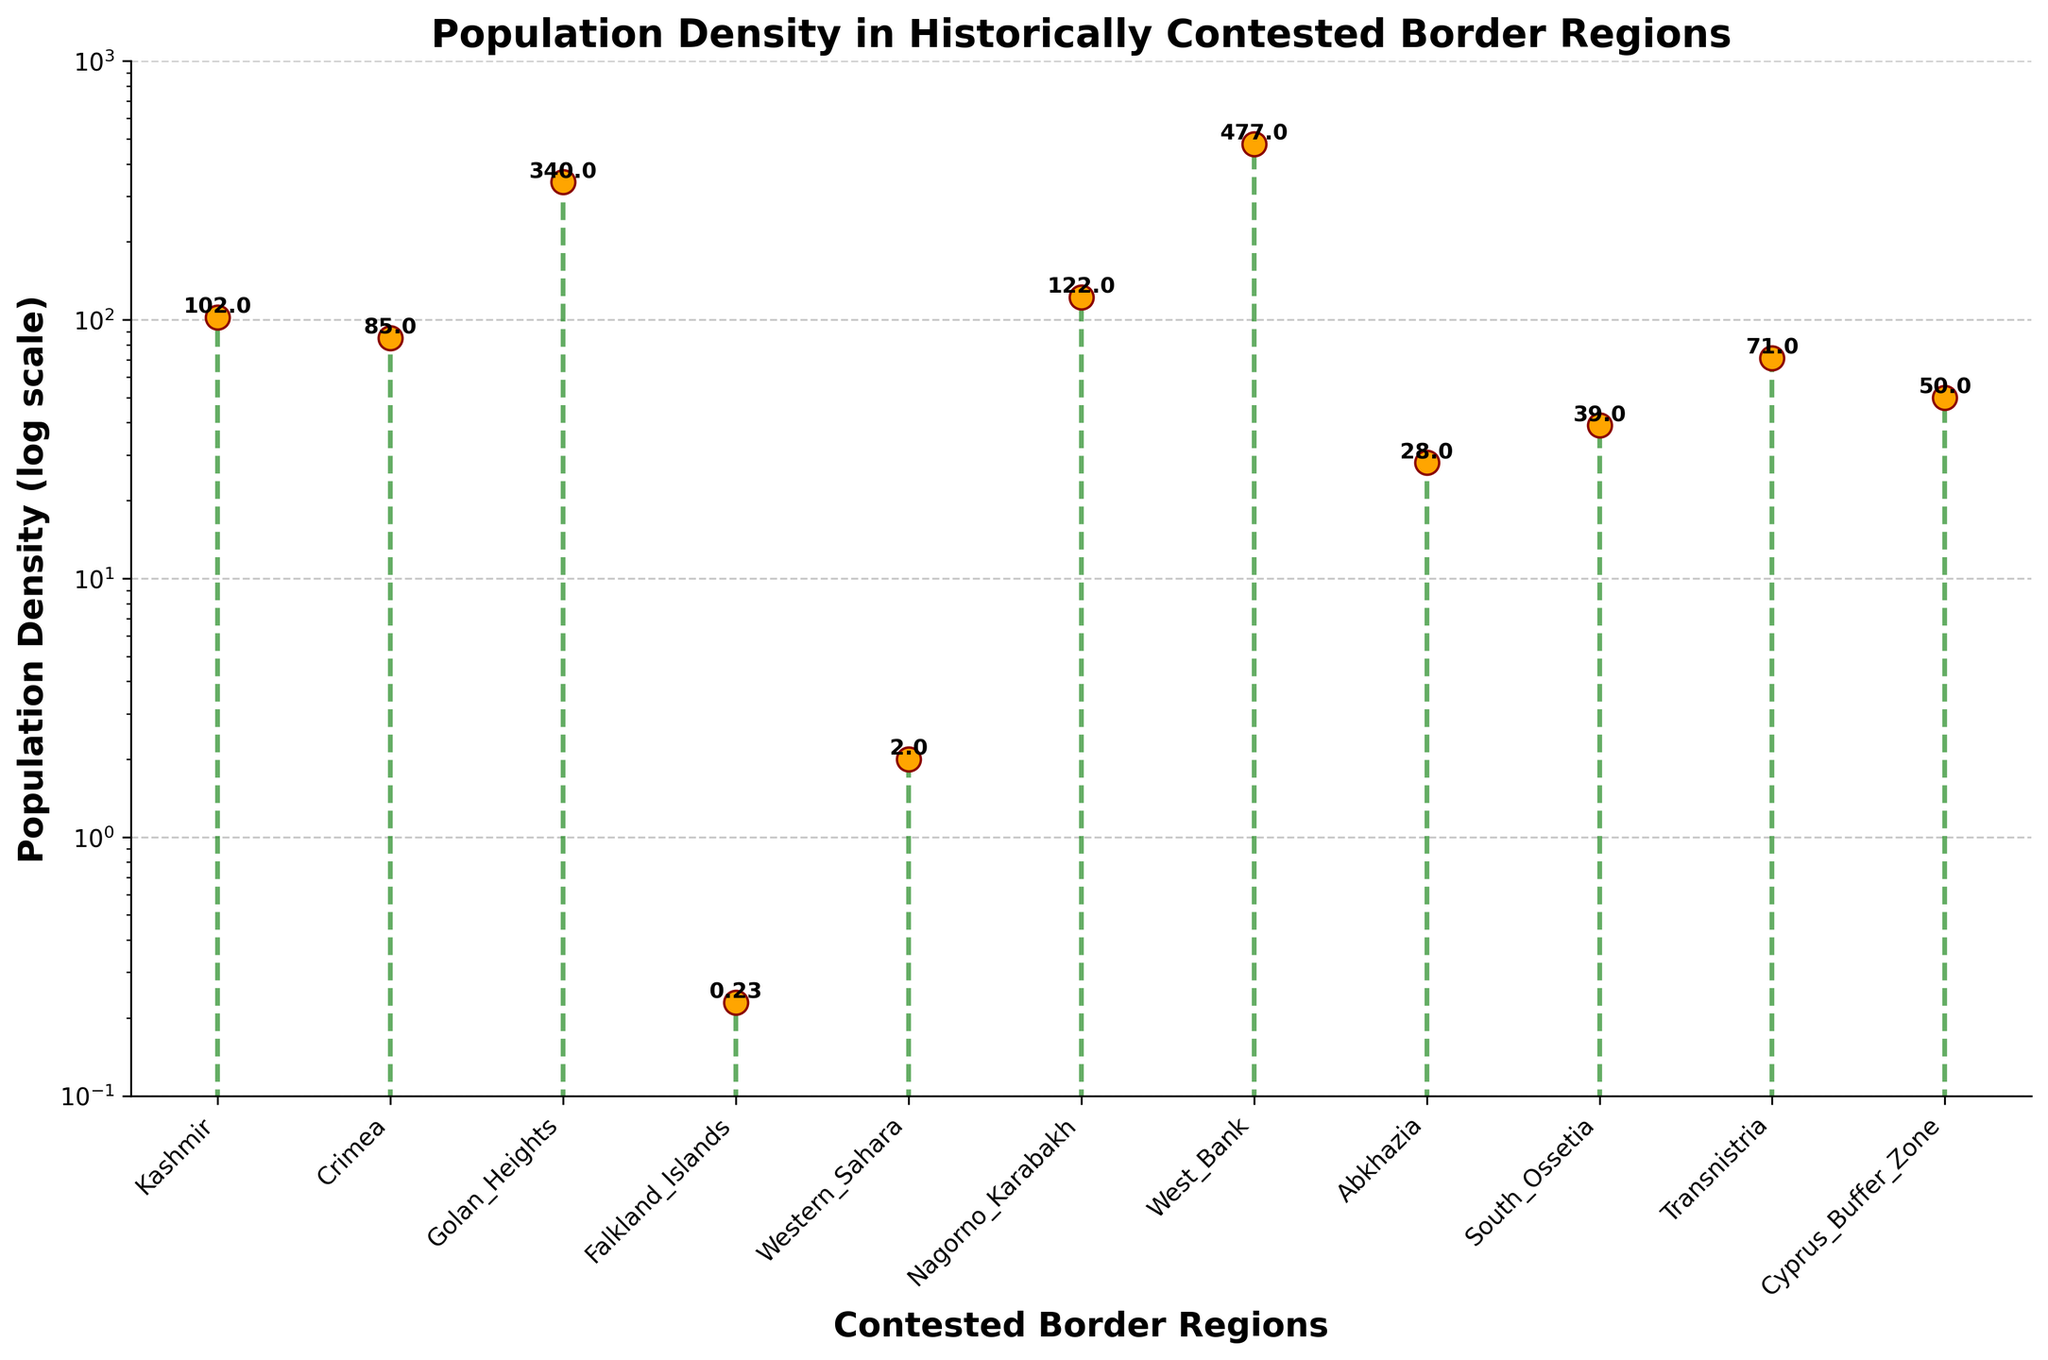What's the title of the figure? The title can be found at the top of the figure. It reads "Population Density in Historically Contested Border Regions."
Answer: Population Density in Historically Contested Border Regions How many contested border regions are shown in the plot? The number of regions can be determined by counting the data points on the x-axis. Each point corresponds to one region.
Answer: 11 Which region has the highest population density? To find the region with the highest density, look for the tallest marker on the plot. The highest marker corresponds to the West Bank.
Answer: West Bank Which region has the lowest population density? To find the region with the lowest density, look for the shortest marker on the plot. The lowest marker corresponds to the Falkland Islands.
Answer: Falkland Islands What is the population density of Kashmir? Locate the marker representing Kashmir on the x-axis and read its corresponding y-value. The density for Kashmir is marked as 102.
Answer: 102 How does the population density of the Golan Heights compare to that of Nagorno-Karabakh? Compare the heights of the markers for the Golan Heights and Nagorno-Karabakh. The Golan Heights has a higher marker, indicating a higher population density (340 vs. 122).
Answer: Golan Heights has a higher density What's the median population density of these regions? To find the median, first list the population densities in ascending order: 0.23, 2, 28, 39, 50, 71, 85, 102, 122, 340, 477. The median is the middle value in this ordered list, which is 71.
Answer: 71 How many regions have a population density above 100? Count the markers that have y-values greater than 100: Kashmir, Golan Heights, Nagorno-Karabakh, West Bank, and Crimea. There are 5 such regions.
Answer: 5 What is the average population density of regions with density below 50? First, identify the densities below 50: Falkland Islands (0.23), Western Sahara (2), Abkhazia (28), South Ossetia (39), and Cyprus Buffer Zone (50 is not below 50). Sum these values: 0.23 + 2 + 28 + 39 = 69.23. Divide this sum by the number of these regions (4): 69.23/4 = 17.31.
Answer: 17.31 How is the stem "line" visually represented in the figure? The stem lines are depicted using green lines connecting the baseline to the markers, with a dashed gray line for the overall line format.
Answer: Green lines with dashed gray base 